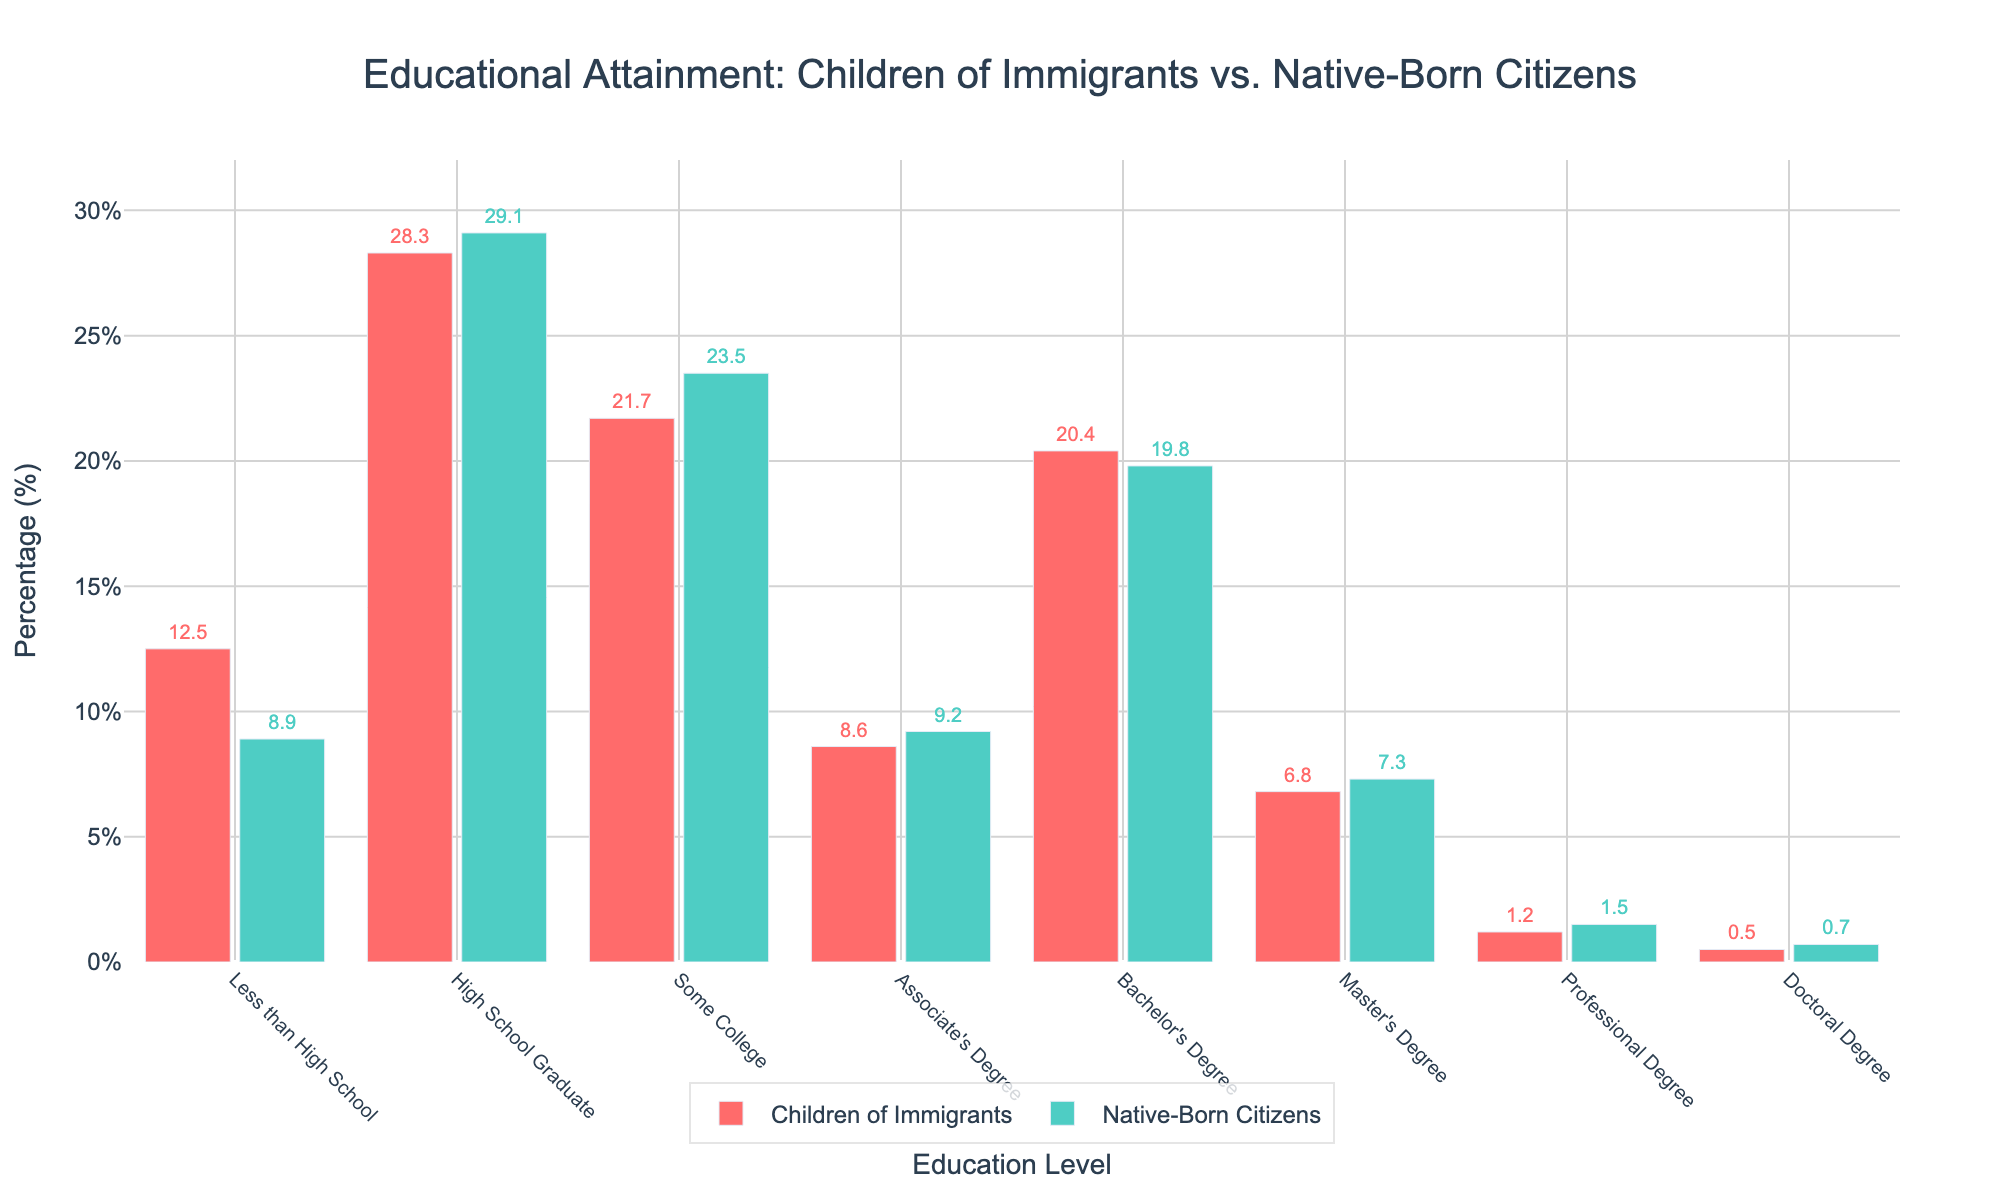What educational attainment level has the highest percentage among native-born citizens? The bar labeled "High School Graduate" for native-born citizens is the tallest among the bars representing native-born citizens.
Answer: High School Graduate What educational attainment level has the lowest percentage among children of immigrants? The bar labeled "Doctoral Degree" for children of immigrants is the shortest among all bars representing children of immigrants.
Answer: Doctoral Degree Which group has a higher percentage of Bachelor’s Degree holders, children of immigrants or native-born citizens? The bar for children of immigrants at the "Bachelor's Degree" level is slightly higher than the bar for native-born citizens at the same level.
Answer: Children of Immigrants What is the difference in percentage points between children of immigrants and native-born citizens who are high school graduates? The percentage for children of immigrants is 28.3% and for native-born citizens is 29.1%. The difference is 29.1% - 28.3%.
Answer: 0.8% What percentage of children of immigrants have achieved a Master’s Degree? The bar labeled "Master's Degree" for children of immigrants shows a value of 6.8%.
Answer: 6.8% Which group shows a greater percentage of individuals with some college education? The bars for both groups at the "Some College" level can be compared visually, with native-born citizens having a slightly higher percentage than children of immigrants.
Answer: Native-Born Citizens If you sum the percentages of children of immigrants who have obtained a Bachelor's Degree and an Associate's Degree, what is the total? The sum of 20.4% (Bachelor's Degree) and 8.6% (Associate's Degree) for children of immigrants is calculated.
Answer: 29% What percentage point difference exists between children of immigrants and native-born citizens with less than a high school education? The percentage for children of immigrants is 12.5% and for native-born citizens is 8.9%. The difference is 12.5% - 8.9%.
Answer: 3.6% What educational level shows the closest percentage values between the two groups? Comparing percentages visually, "High School Graduate" and "Bachelor's Degree" both show close values, with "High School Graduate" having the closest difference (0.8%).
Answer: High School Graduate 